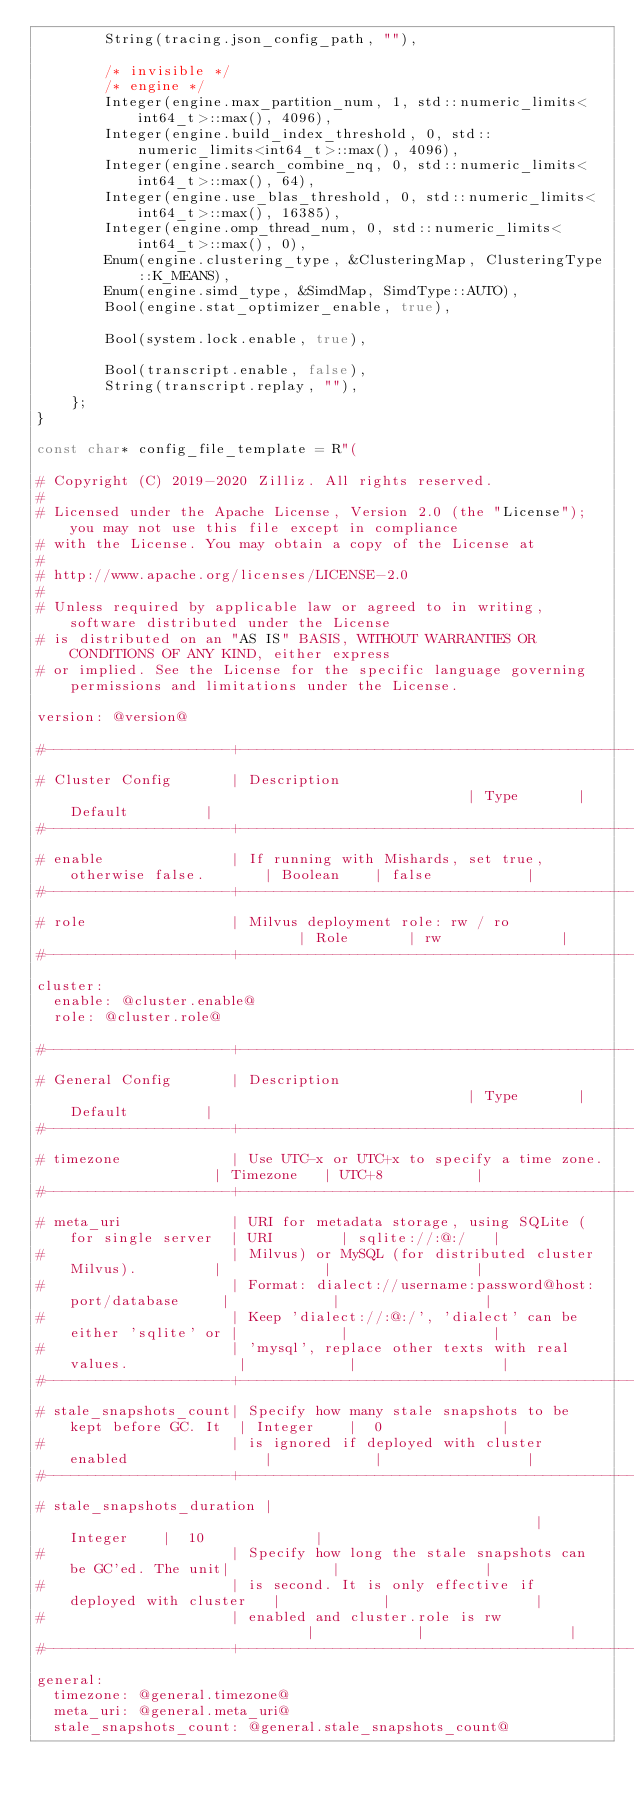<code> <loc_0><loc_0><loc_500><loc_500><_C++_>        String(tracing.json_config_path, ""),

        /* invisible */
        /* engine */
        Integer(engine.max_partition_num, 1, std::numeric_limits<int64_t>::max(), 4096),
        Integer(engine.build_index_threshold, 0, std::numeric_limits<int64_t>::max(), 4096),
        Integer(engine.search_combine_nq, 0, std::numeric_limits<int64_t>::max(), 64),
        Integer(engine.use_blas_threshold, 0, std::numeric_limits<int64_t>::max(), 16385),
        Integer(engine.omp_thread_num, 0, std::numeric_limits<int64_t>::max(), 0),
        Enum(engine.clustering_type, &ClusteringMap, ClusteringType::K_MEANS),
        Enum(engine.simd_type, &SimdMap, SimdType::AUTO),
        Bool(engine.stat_optimizer_enable, true),

        Bool(system.lock.enable, true),

        Bool(transcript.enable, false),
        String(transcript.replay, ""),
    };
}

const char* config_file_template = R"(

# Copyright (C) 2019-2020 Zilliz. All rights reserved.
#
# Licensed under the Apache License, Version 2.0 (the "License"); you may not use this file except in compliance
# with the License. You may obtain a copy of the License at
#
# http://www.apache.org/licenses/LICENSE-2.0
#
# Unless required by applicable law or agreed to in writing, software distributed under the License
# is distributed on an "AS IS" BASIS, WITHOUT WARRANTIES OR CONDITIONS OF ANY KIND, either express
# or implied. See the License for the specific language governing permissions and limitations under the License.

version: @version@

#----------------------+------------------------------------------------------------+------------+-----------------+
# Cluster Config       | Description                                                | Type       | Default         |
#----------------------+------------------------------------------------------------+------------+-----------------+
# enable               | If running with Mishards, set true, otherwise false.       | Boolean    | false           |
#----------------------+------------------------------------------------------------+------------+-----------------+
# role                 | Milvus deployment role: rw / ro                            | Role       | rw              |
#----------------------+------------------------------------------------------------+------------+-----------------+
cluster:
  enable: @cluster.enable@
  role: @cluster.role@

#----------------------+------------------------------------------------------------+------------+-----------------+
# General Config       | Description                                                | Type       | Default         |
#----------------------+------------------------------------------------------------+------------+-----------------+
# timezone             | Use UTC-x or UTC+x to specify a time zone.                 | Timezone   | UTC+8           |
#----------------------+------------------------------------------------------------+------------+-----------------+
# meta_uri             | URI for metadata storage, using SQLite (for single server  | URI        | sqlite://:@:/   |
#                      | Milvus) or MySQL (for distributed cluster Milvus).         |            |                 |
#                      | Format: dialect://username:password@host:port/database     |            |                 |
#                      | Keep 'dialect://:@:/', 'dialect' can be either 'sqlite' or |            |                 |
#                      | 'mysql', replace other texts with real values.             |            |                 |
#----------------------+------------------------------------------------------------+------------+-----------------+
# stale_snapshots_count| Specify how many stale snapshots to be kept before GC. It  | Integer    |  0              |
#                      | is ignored if deployed with cluster enabled                |            |                 |
#----------------------+------------------------------------------------------------+------------+-----------------+
# stale_snapshots_duration |                                                        | Integer    |  10             |
#                      | Specify how long the stale snapshots can be GC'ed. The unit|            |                 |
#                      | is second. It is only effective if deployed with cluster   |            |                 |
#                      | enabled and cluster.role is rw                             |            |                 |
#----------------------+------------------------------------------------------------+------------+-----------------+
general:
  timezone: @general.timezone@
  meta_uri: @general.meta_uri@
  stale_snapshots_count: @general.stale_snapshots_count@</code> 